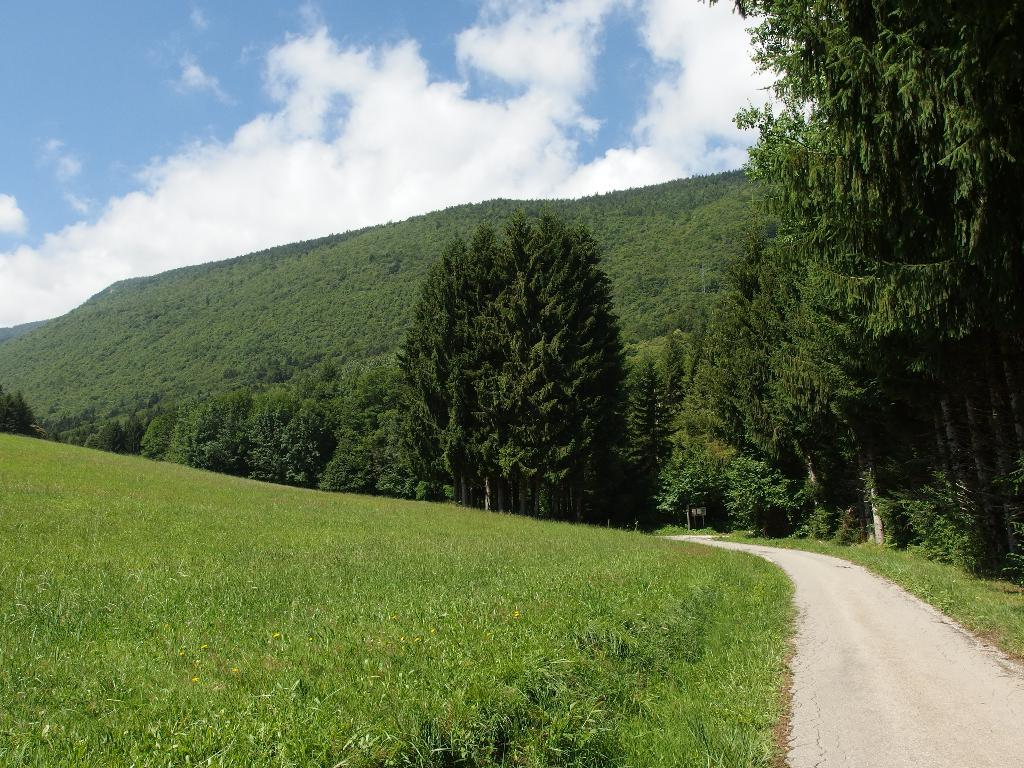What is located at the bottom of the image? There are plants, grass, and a road at the bottom of the image. What can be seen in the middle of the image? There are trees, hills, and the sky visible in the middle of the image. What is present in the sky in the middle of the image? There are clouds in the sky in the middle of the image. What is the income of the fruit depicted in the image? There is no fruit present in the image, so it is not possible to determine its income. 